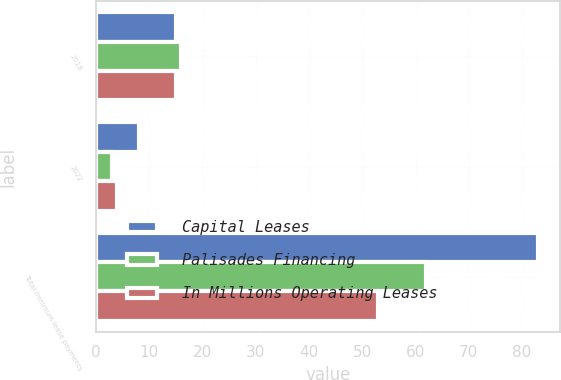Convert chart to OTSL. <chart><loc_0><loc_0><loc_500><loc_500><stacked_bar_chart><ecel><fcel>2018<fcel>2022<fcel>Total minimum lease payments<nl><fcel>Capital Leases<fcel>15<fcel>8<fcel>83<nl><fcel>Palisades Financing<fcel>16<fcel>3<fcel>62<nl><fcel>In Millions Operating Leases<fcel>15<fcel>4<fcel>53<nl></chart> 